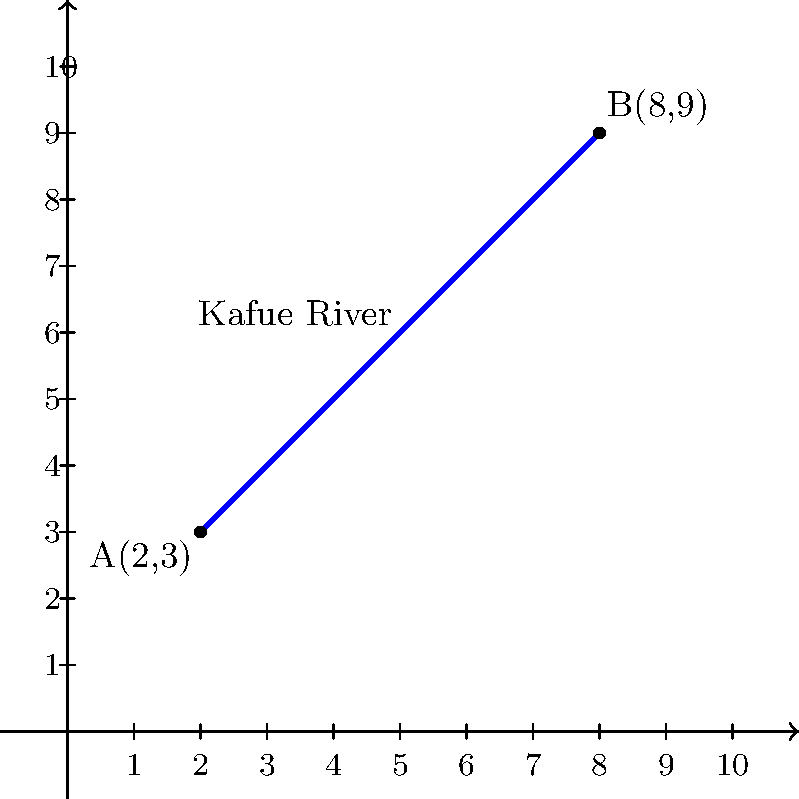As part of a water management project in Zambia, you're analyzing the Kafue River's gradient. The river's course is represented by the blue line on the coordinate system, with points A(2,3) and B(8,9) marking two monitoring stations. Calculate the slope of this section of the Kafue River. How might this information be relevant to environmental legislation and water management policies in Zambia? To calculate the slope of the river section, we'll use the slope formula:

$$ \text{Slope} = \frac{y_2 - y_1}{x_2 - x_1} $$

Where $(x_1, y_1)$ represents point A and $(x_2, y_2)$ represents point B.

Step 1: Identify the coordinates
A(2,3): $x_1 = 2$, $y_1 = 3$
B(8,9): $x_2 = 8$, $y_2 = 9$

Step 2: Apply the slope formula
$$ \text{Slope} = \frac{9 - 3}{8 - 2} = \frac{6}{6} = 1 $$

The slope of this section of the Kafue River is 1, or 1:1.

This information is relevant to environmental legislation and water management policies in Zambia for several reasons:

1. Flood risk assessment: The slope affects water flow velocity, which is crucial for predicting and managing flood risks.

2. Erosion control: Steeper slopes may require more stringent erosion control measures to protect riverbanks and surrounding ecosystems.

3. Water resource management: Understanding river gradients helps in planning water extraction points, reservoirs, and hydroelectric projects.

4. Ecological impact: The slope influences habitat types along the river, which is important for biodiversity conservation policies.

5. Pollution dispersion: River gradient affects how quickly pollutants disperse, informing regulations on effluent discharge and water quality standards.

6. Climate change adaptation: Slope data can help predict how changes in precipitation patterns might affect river flow and surrounding areas.

Understanding these factors allows policymakers to create more effective and targeted environmental legislation for sustainable water management in Zambia.
Answer: Slope = 1 